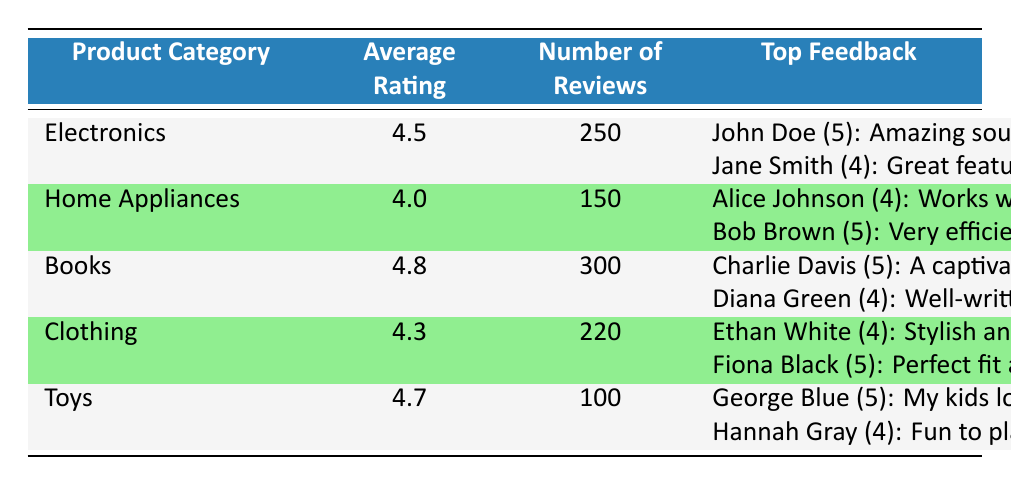What is the average rating for the Electronics category? The table indicates that the average rating for the Electronics category is specifically listed, which is 4.5.
Answer: 4.5 How many reviews are there for the Books category? The number of reviews for the Books category is directly available in the table, which shows a total of 300 reviews.
Answer: 300 Which product category has the highest average rating? By comparing the average ratings listed, Books has the highest average rating at 4.8, followed by Toys at 4.7.
Answer: Books Is the average rating for Home Appliances above 4.0? The average rating for Home Appliances is listed as 4.0. Since it is equal to 4.0, the statement is not true as it is not above that value.
Answer: No How many more reviews does the Clothing category have than Toys? The Clothing category has 220 reviews, while the Toys category has 100 reviews. The difference is calculated as 220 - 100 = 120.
Answer: 120 What is the top feedback for Electronics? The top feedback for the Electronics category includes two reviews listed, one from John Doe with a 5 rating saying "Amazing sound quality!" and another from Jane Smith with a 4 rating saying "Great features but a bit pricey."
Answer: John Doe (5): Amazing sound quality!; Jane Smith (4): Great features but a bit pricey If we combine the number of reviews from Electronics and Home Appliances, how many total reviews do we have? The total reviews for Electronics is 250 and for Home Appliances is 150. By adding these two together, we get 250 + 150 = 400.
Answer: 400 Which category has the lowest number of reviews? Comparing the number of reviews across all categories, Toys has the fewest reviews with only 100.
Answer: Toys Do all product categories have an average rating of 4 or higher? By analyzing the average ratings in the table, Electronics, Home Appliances, Books, Clothing, and Toys all have ratings above 4, confirming that all product categories do indeed meet this criterion.
Answer: Yes 